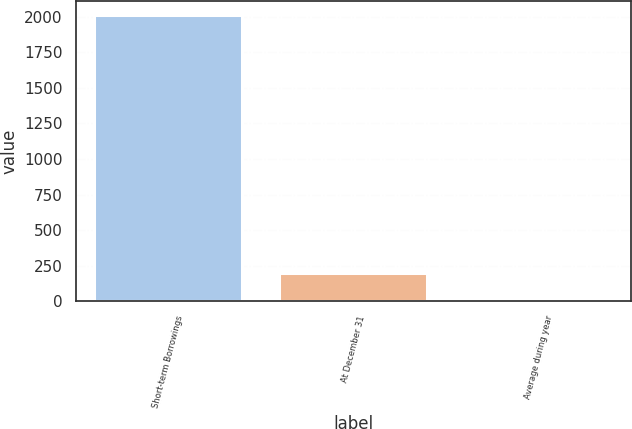Convert chart to OTSL. <chart><loc_0><loc_0><loc_500><loc_500><bar_chart><fcel>Short-term Borrowings<fcel>At December 31<fcel>Average during year<nl><fcel>2009<fcel>200.95<fcel>0.05<nl></chart> 